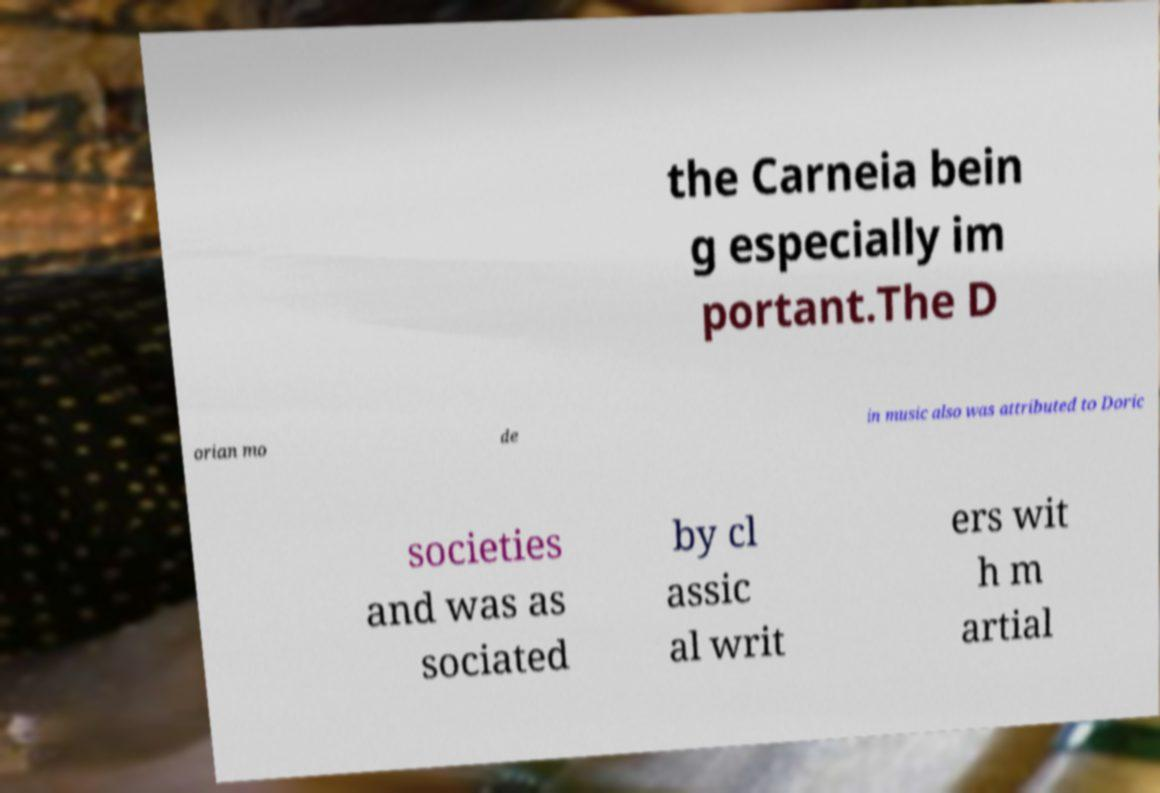Could you assist in decoding the text presented in this image and type it out clearly? the Carneia bein g especially im portant.The D orian mo de in music also was attributed to Doric societies and was as sociated by cl assic al writ ers wit h m artial 